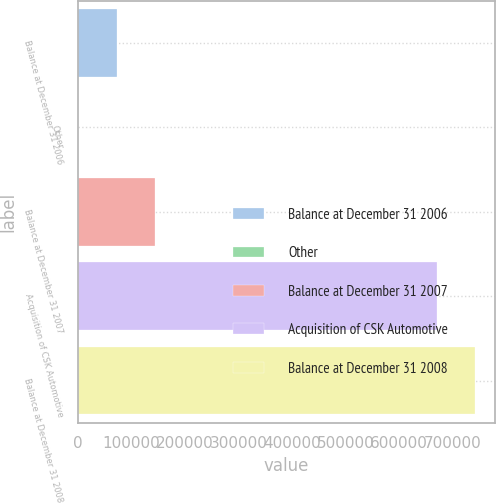Convert chart to OTSL. <chart><loc_0><loc_0><loc_500><loc_500><bar_chart><fcel>Balance at December 31 2006<fcel>Other<fcel>Balance at December 31 2007<fcel>Acquisition of CSK Automotive<fcel>Balance at December 31 2008<nl><fcel>73294.6<fcel>1382<fcel>145207<fcel>670508<fcel>742421<nl></chart> 